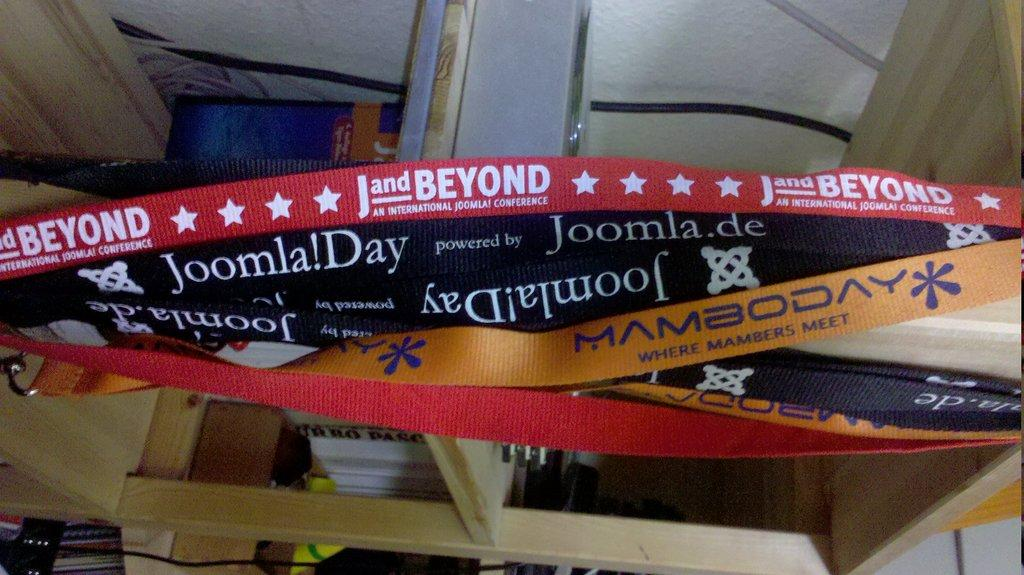<image>
Write a terse but informative summary of the picture. A bunch of lanyards from different conferences are labeled with names like J and Beyond and Joomla!Day. 